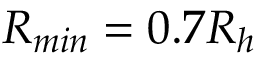<formula> <loc_0><loc_0><loc_500><loc_500>R _ { \min } = 0 . 7 R _ { h }</formula> 